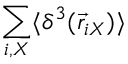Convert formula to latex. <formula><loc_0><loc_0><loc_500><loc_500>\sum _ { i , X } \langle \delta ^ { 3 } ( \vec { r } _ { i X } ) \rangle</formula> 